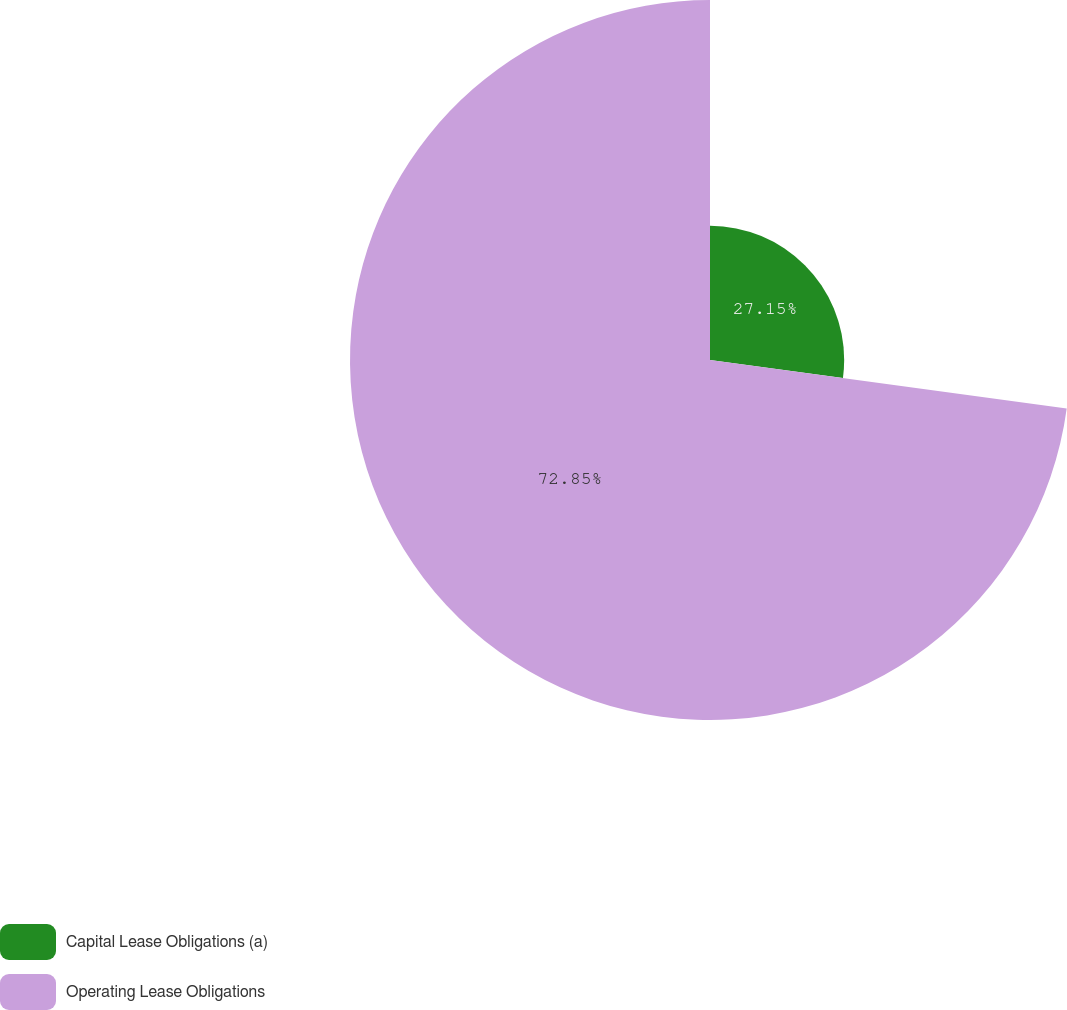Convert chart. <chart><loc_0><loc_0><loc_500><loc_500><pie_chart><fcel>Capital Lease Obligations (a)<fcel>Operating Lease Obligations<nl><fcel>27.15%<fcel>72.85%<nl></chart> 